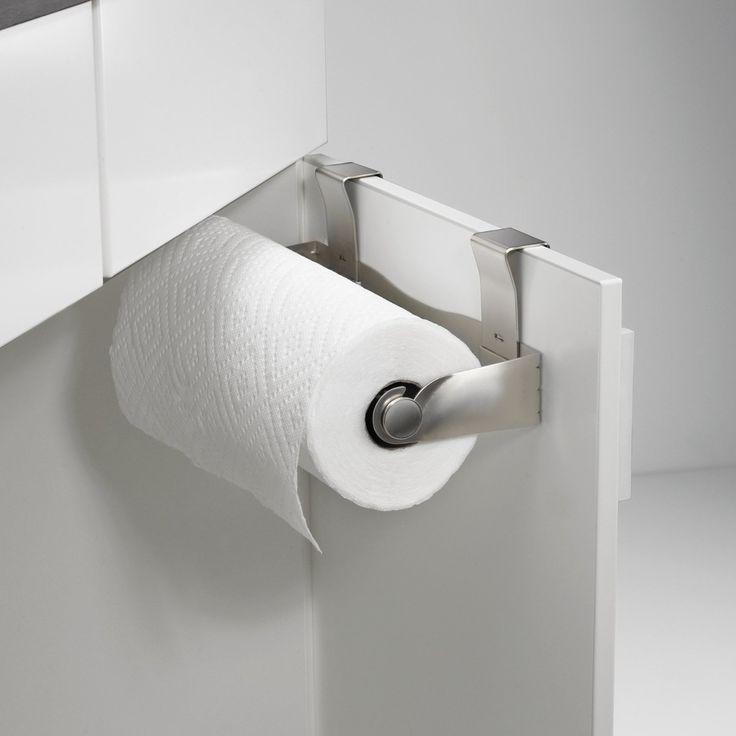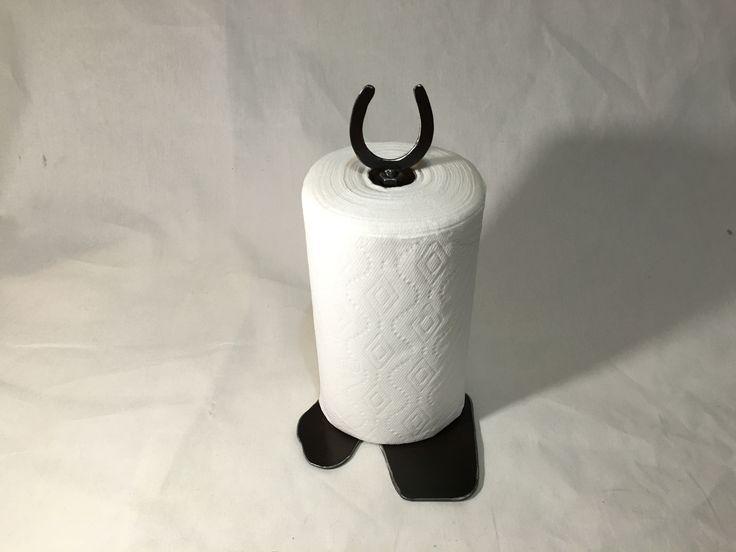The first image is the image on the left, the second image is the image on the right. Analyze the images presented: Is the assertion "An image shows one towel row mounted horizontally, with a sheet hanging toward the left." valid? Answer yes or no. Yes. The first image is the image on the left, the second image is the image on the right. For the images displayed, is the sentence "In one image, a roll of paper towels is attached to a chrome hanging towel holder, while a second image shows a roll of paper towels on an upright towel holder." factually correct? Answer yes or no. Yes. 